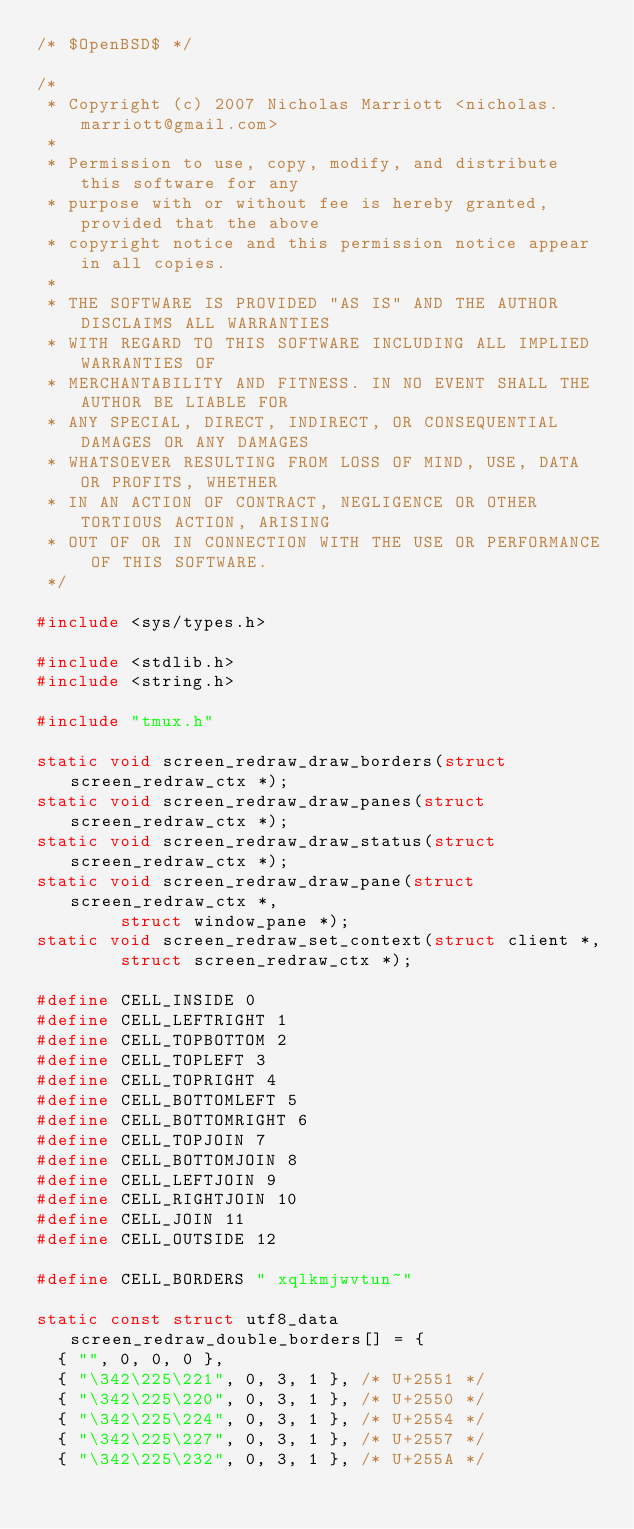Convert code to text. <code><loc_0><loc_0><loc_500><loc_500><_C_>/* $OpenBSD$ */

/*
 * Copyright (c) 2007 Nicholas Marriott <nicholas.marriott@gmail.com>
 *
 * Permission to use, copy, modify, and distribute this software for any
 * purpose with or without fee is hereby granted, provided that the above
 * copyright notice and this permission notice appear in all copies.
 *
 * THE SOFTWARE IS PROVIDED "AS IS" AND THE AUTHOR DISCLAIMS ALL WARRANTIES
 * WITH REGARD TO THIS SOFTWARE INCLUDING ALL IMPLIED WARRANTIES OF
 * MERCHANTABILITY AND FITNESS. IN NO EVENT SHALL THE AUTHOR BE LIABLE FOR
 * ANY SPECIAL, DIRECT, INDIRECT, OR CONSEQUENTIAL DAMAGES OR ANY DAMAGES
 * WHATSOEVER RESULTING FROM LOSS OF MIND, USE, DATA OR PROFITS, WHETHER
 * IN AN ACTION OF CONTRACT, NEGLIGENCE OR OTHER TORTIOUS ACTION, ARISING
 * OUT OF OR IN CONNECTION WITH THE USE OR PERFORMANCE OF THIS SOFTWARE.
 */

#include <sys/types.h>

#include <stdlib.h>
#include <string.h>

#include "tmux.h"

static void	screen_redraw_draw_borders(struct screen_redraw_ctx *);
static void	screen_redraw_draw_panes(struct screen_redraw_ctx *);
static void	screen_redraw_draw_status(struct screen_redraw_ctx *);
static void	screen_redraw_draw_pane(struct screen_redraw_ctx *,
		    struct window_pane *);
static void	screen_redraw_set_context(struct client *,
		    struct screen_redraw_ctx *);

#define CELL_INSIDE 0
#define CELL_LEFTRIGHT 1
#define CELL_TOPBOTTOM 2
#define CELL_TOPLEFT 3
#define CELL_TOPRIGHT 4
#define CELL_BOTTOMLEFT 5
#define CELL_BOTTOMRIGHT 6
#define CELL_TOPJOIN 7
#define CELL_BOTTOMJOIN 8
#define CELL_LEFTJOIN 9
#define CELL_RIGHTJOIN 10
#define CELL_JOIN 11
#define CELL_OUTSIDE 12

#define CELL_BORDERS " xqlkmjwvtun~"

static const struct utf8_data screen_redraw_double_borders[] = {
	{ "", 0, 0, 0 },
	{ "\342\225\221", 0, 3, 1 }, /* U+2551 */
	{ "\342\225\220", 0, 3, 1 }, /* U+2550 */
	{ "\342\225\224", 0, 3, 1 }, /* U+2554 */
	{ "\342\225\227", 0, 3, 1 }, /* U+2557 */
	{ "\342\225\232", 0, 3, 1 }, /* U+255A */</code> 